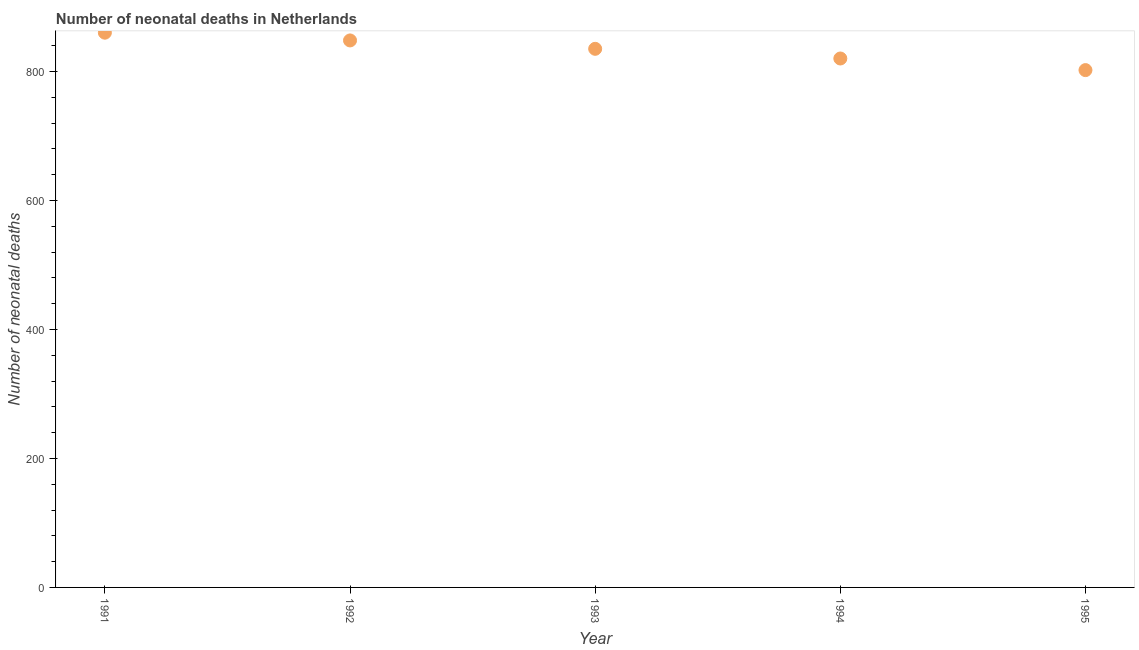What is the number of neonatal deaths in 1995?
Offer a very short reply. 802. Across all years, what is the maximum number of neonatal deaths?
Offer a terse response. 860. Across all years, what is the minimum number of neonatal deaths?
Your answer should be compact. 802. In which year was the number of neonatal deaths maximum?
Your answer should be very brief. 1991. What is the sum of the number of neonatal deaths?
Give a very brief answer. 4165. What is the difference between the number of neonatal deaths in 1991 and 1994?
Provide a succinct answer. 40. What is the average number of neonatal deaths per year?
Provide a short and direct response. 833. What is the median number of neonatal deaths?
Your response must be concise. 835. In how many years, is the number of neonatal deaths greater than 240 ?
Provide a short and direct response. 5. What is the ratio of the number of neonatal deaths in 1993 to that in 1995?
Your response must be concise. 1.04. Is the number of neonatal deaths in 1993 less than that in 1994?
Offer a very short reply. No. What is the difference between the highest and the second highest number of neonatal deaths?
Ensure brevity in your answer.  12. What is the difference between the highest and the lowest number of neonatal deaths?
Provide a short and direct response. 58. How many dotlines are there?
Your answer should be very brief. 1. Does the graph contain any zero values?
Ensure brevity in your answer.  No. What is the title of the graph?
Keep it short and to the point. Number of neonatal deaths in Netherlands. What is the label or title of the Y-axis?
Provide a short and direct response. Number of neonatal deaths. What is the Number of neonatal deaths in 1991?
Give a very brief answer. 860. What is the Number of neonatal deaths in 1992?
Your answer should be compact. 848. What is the Number of neonatal deaths in 1993?
Offer a very short reply. 835. What is the Number of neonatal deaths in 1994?
Offer a very short reply. 820. What is the Number of neonatal deaths in 1995?
Offer a very short reply. 802. What is the difference between the Number of neonatal deaths in 1991 and 1992?
Offer a very short reply. 12. What is the difference between the Number of neonatal deaths in 1991 and 1994?
Offer a very short reply. 40. What is the difference between the Number of neonatal deaths in 1992 and 1993?
Offer a terse response. 13. What is the difference between the Number of neonatal deaths in 1992 and 1995?
Make the answer very short. 46. What is the difference between the Number of neonatal deaths in 1993 and 1994?
Your response must be concise. 15. What is the difference between the Number of neonatal deaths in 1994 and 1995?
Make the answer very short. 18. What is the ratio of the Number of neonatal deaths in 1991 to that in 1993?
Ensure brevity in your answer.  1.03. What is the ratio of the Number of neonatal deaths in 1991 to that in 1994?
Provide a succinct answer. 1.05. What is the ratio of the Number of neonatal deaths in 1991 to that in 1995?
Your answer should be very brief. 1.07. What is the ratio of the Number of neonatal deaths in 1992 to that in 1994?
Your answer should be very brief. 1.03. What is the ratio of the Number of neonatal deaths in 1992 to that in 1995?
Your response must be concise. 1.06. What is the ratio of the Number of neonatal deaths in 1993 to that in 1995?
Provide a succinct answer. 1.04. What is the ratio of the Number of neonatal deaths in 1994 to that in 1995?
Provide a succinct answer. 1.02. 